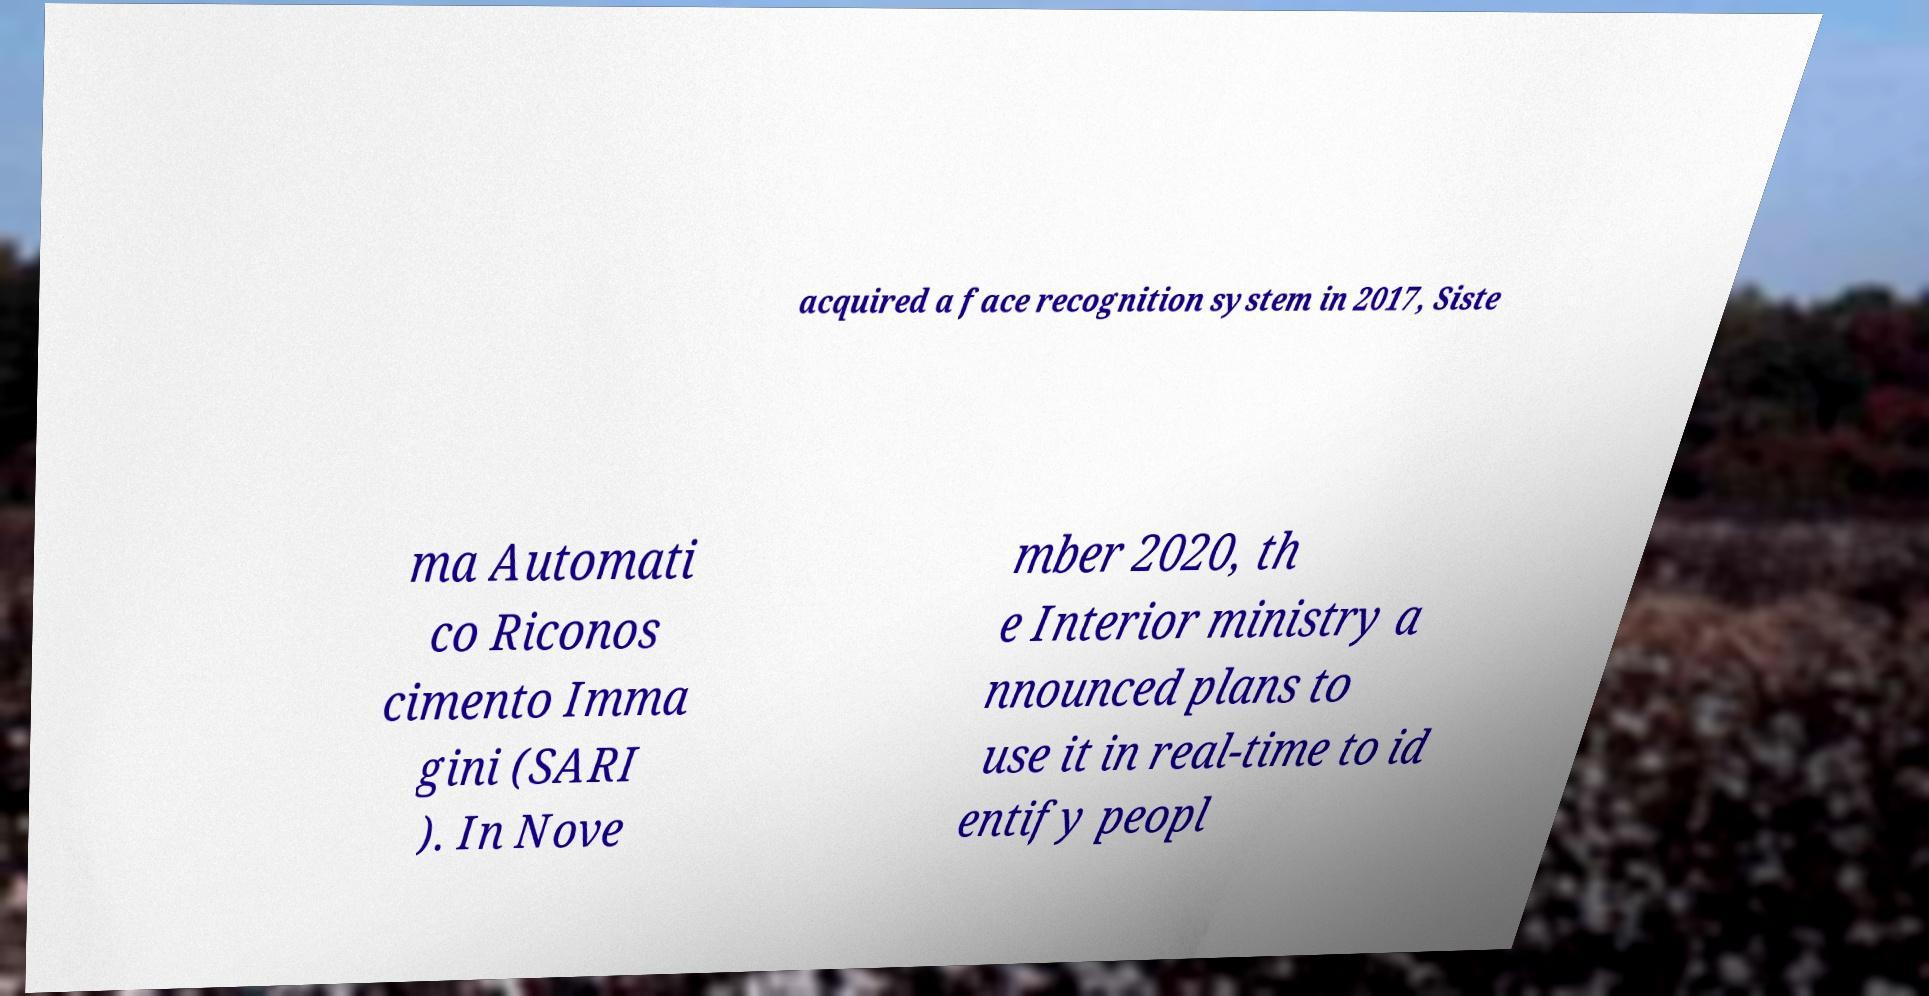What messages or text are displayed in this image? I need them in a readable, typed format. acquired a face recognition system in 2017, Siste ma Automati co Riconos cimento Imma gini (SARI ). In Nove mber 2020, th e Interior ministry a nnounced plans to use it in real-time to id entify peopl 